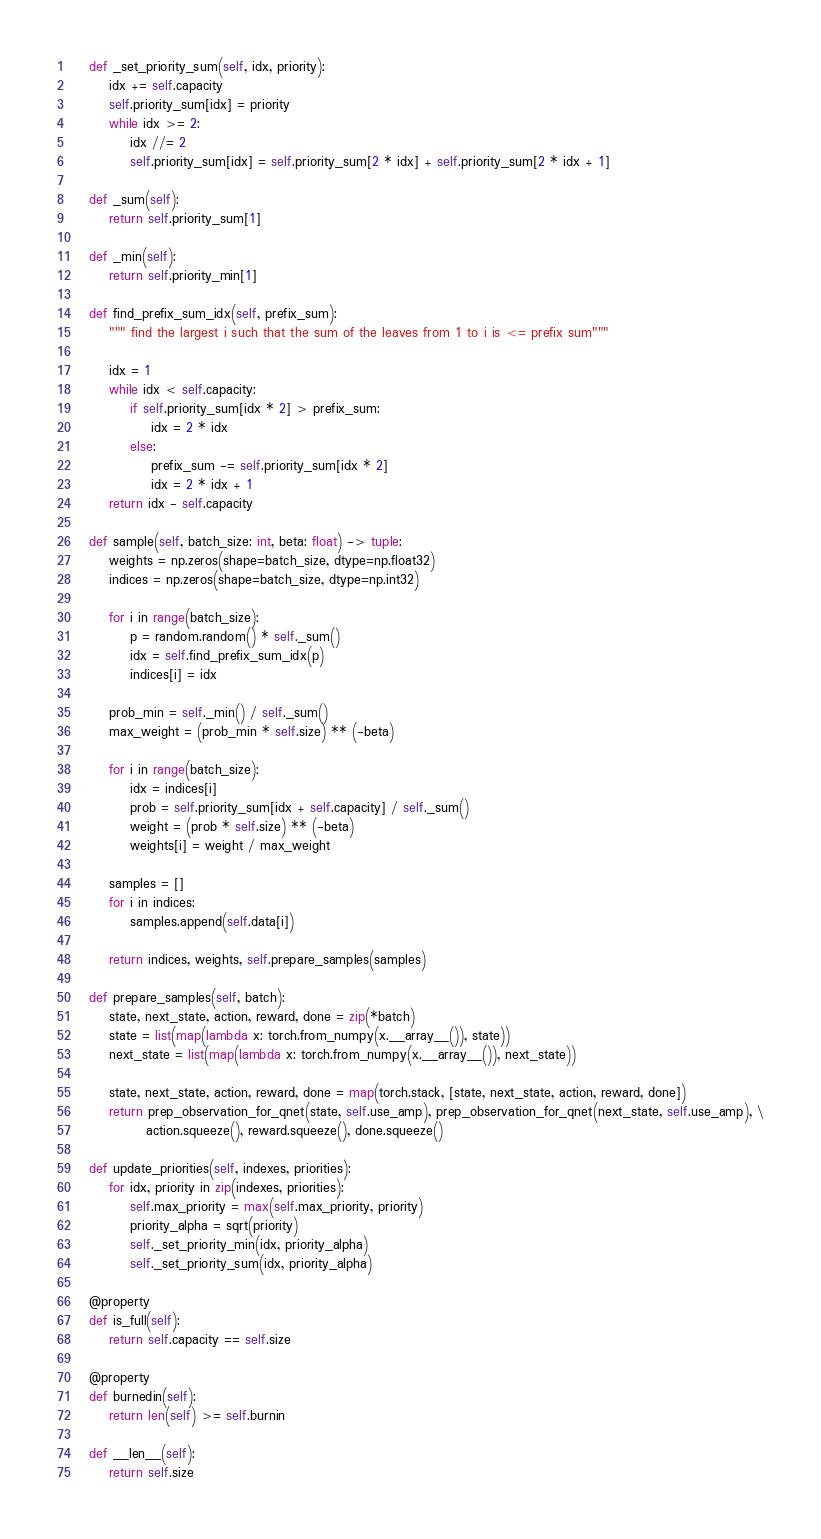<code> <loc_0><loc_0><loc_500><loc_500><_Python_>
    def _set_priority_sum(self, idx, priority):
        idx += self.capacity
        self.priority_sum[idx] = priority
        while idx >= 2:
            idx //= 2
            self.priority_sum[idx] = self.priority_sum[2 * idx] + self.priority_sum[2 * idx + 1]

    def _sum(self):
        return self.priority_sum[1]

    def _min(self):
        return self.priority_min[1]

    def find_prefix_sum_idx(self, prefix_sum):
        """ find the largest i such that the sum of the leaves from 1 to i is <= prefix sum"""

        idx = 1
        while idx < self.capacity:
            if self.priority_sum[idx * 2] > prefix_sum:
                idx = 2 * idx
            else:
                prefix_sum -= self.priority_sum[idx * 2]
                idx = 2 * idx + 1
        return idx - self.capacity

    def sample(self, batch_size: int, beta: float) -> tuple:
        weights = np.zeros(shape=batch_size, dtype=np.float32)
        indices = np.zeros(shape=batch_size, dtype=np.int32)

        for i in range(batch_size):
            p = random.random() * self._sum()
            idx = self.find_prefix_sum_idx(p)
            indices[i] = idx

        prob_min = self._min() / self._sum()
        max_weight = (prob_min * self.size) ** (-beta)

        for i in range(batch_size):
            idx = indices[i]
            prob = self.priority_sum[idx + self.capacity] / self._sum()
            weight = (prob * self.size) ** (-beta)
            weights[i] = weight / max_weight

        samples = []
        for i in indices:
            samples.append(self.data[i])

        return indices, weights, self.prepare_samples(samples)

    def prepare_samples(self, batch):
        state, next_state, action, reward, done = zip(*batch)
        state = list(map(lambda x: torch.from_numpy(x.__array__()), state))
        next_state = list(map(lambda x: torch.from_numpy(x.__array__()), next_state))

        state, next_state, action, reward, done = map(torch.stack, [state, next_state, action, reward, done])
        return prep_observation_for_qnet(state, self.use_amp), prep_observation_for_qnet(next_state, self.use_amp), \
               action.squeeze(), reward.squeeze(), done.squeeze()

    def update_priorities(self, indexes, priorities):
        for idx, priority in zip(indexes, priorities):
            self.max_priority = max(self.max_priority, priority)
            priority_alpha = sqrt(priority)
            self._set_priority_min(idx, priority_alpha)
            self._set_priority_sum(idx, priority_alpha)

    @property
    def is_full(self):
        return self.capacity == self.size

    @property
    def burnedin(self):
        return len(self) >= self.burnin

    def __len__(self):
        return self.size

</code> 